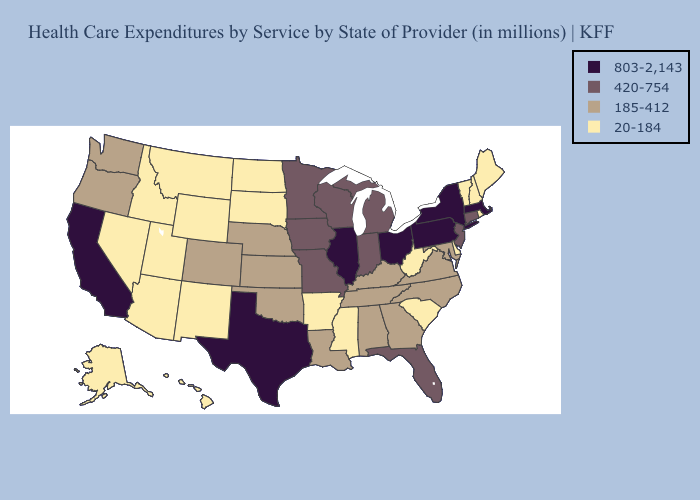Does Mississippi have the same value as Nebraska?
Answer briefly. No. What is the lowest value in the MidWest?
Concise answer only. 20-184. What is the lowest value in states that border Maryland?
Give a very brief answer. 20-184. Among the states that border Utah , does New Mexico have the lowest value?
Quick response, please. Yes. Does the map have missing data?
Write a very short answer. No. Is the legend a continuous bar?
Quick response, please. No. What is the value of New Hampshire?
Answer briefly. 20-184. What is the value of Maine?
Keep it brief. 20-184. Which states have the highest value in the USA?
Give a very brief answer. California, Illinois, Massachusetts, New York, Ohio, Pennsylvania, Texas. Which states have the lowest value in the USA?
Write a very short answer. Alaska, Arizona, Arkansas, Delaware, Hawaii, Idaho, Maine, Mississippi, Montana, Nevada, New Hampshire, New Mexico, North Dakota, Rhode Island, South Carolina, South Dakota, Utah, Vermont, West Virginia, Wyoming. Among the states that border Rhode Island , does Connecticut have the lowest value?
Be succinct. Yes. Name the states that have a value in the range 185-412?
Keep it brief. Alabama, Colorado, Georgia, Kansas, Kentucky, Louisiana, Maryland, Nebraska, North Carolina, Oklahoma, Oregon, Tennessee, Virginia, Washington. Is the legend a continuous bar?
Quick response, please. No. What is the highest value in the Northeast ?
Answer briefly. 803-2,143. What is the value of Missouri?
Write a very short answer. 420-754. 